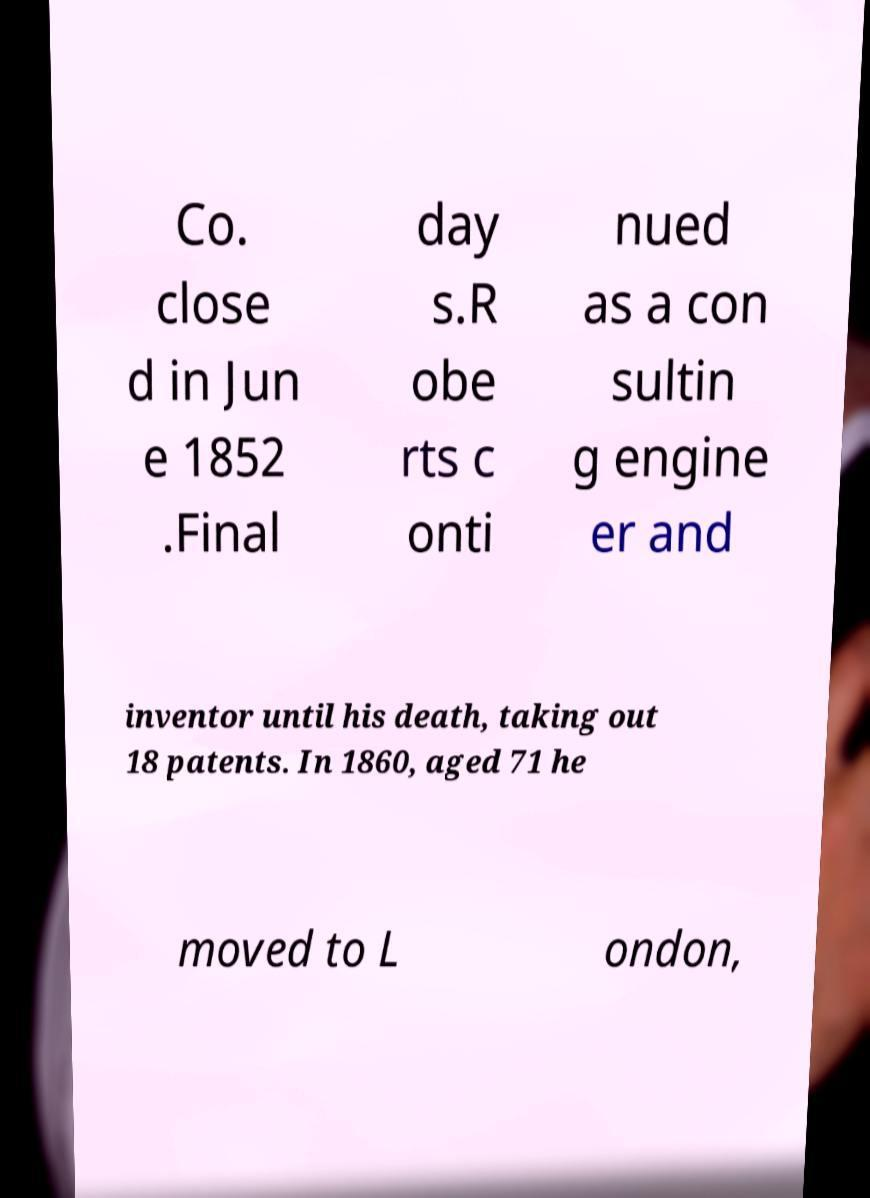Can you accurately transcribe the text from the provided image for me? Co. close d in Jun e 1852 .Final day s.R obe rts c onti nued as a con sultin g engine er and inventor until his death, taking out 18 patents. In 1860, aged 71 he moved to L ondon, 